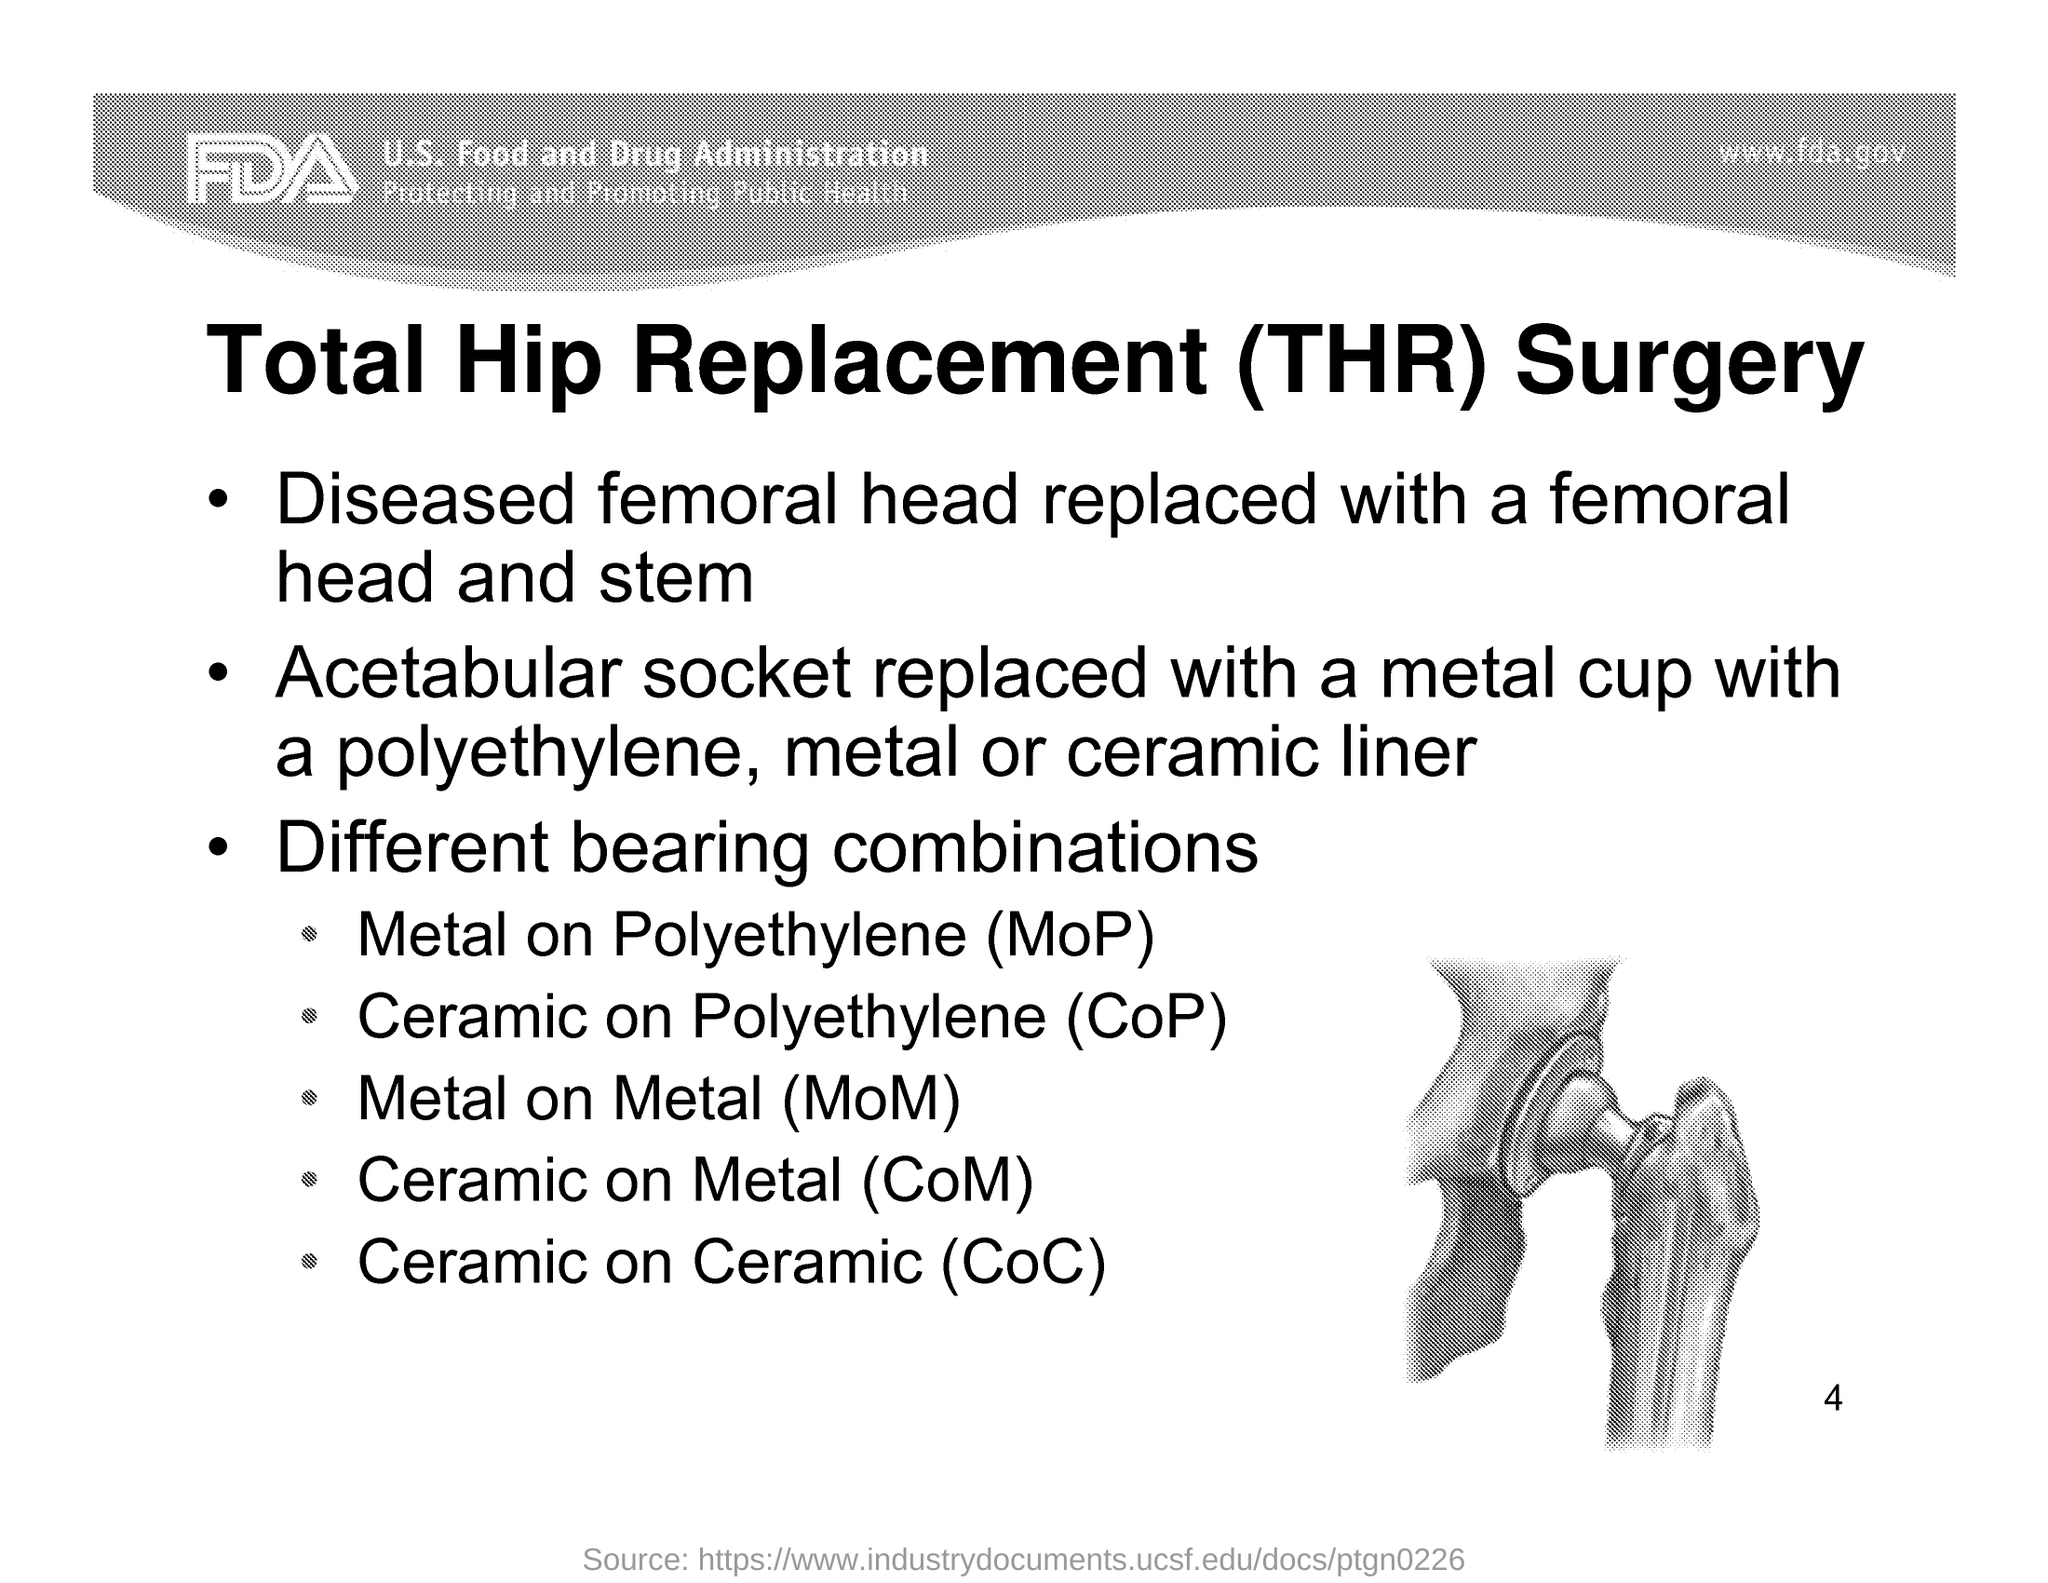Highlight a few significant elements in this photo. The page number is 4, as declared. The website specified in the document is [www.fda.gov](http://www.fda.gov). 